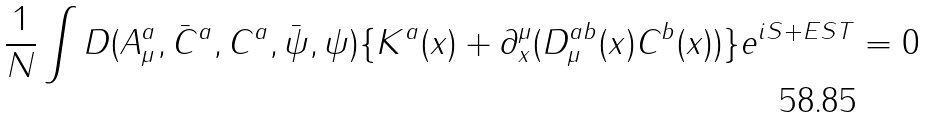Convert formula to latex. <formula><loc_0><loc_0><loc_500><loc_500>\frac { 1 } { N } \int D ( A _ { \mu } ^ { a } , \bar { C } ^ { a } , C ^ { a } , \bar { \psi } , \psi ) \{ K ^ { a } ( x ) + \partial _ { x } ^ { \mu } ( D _ { \mu } ^ { a b } ( x ) C ^ { b } ( x ) ) \} e ^ { i S + E S T } = 0</formula> 